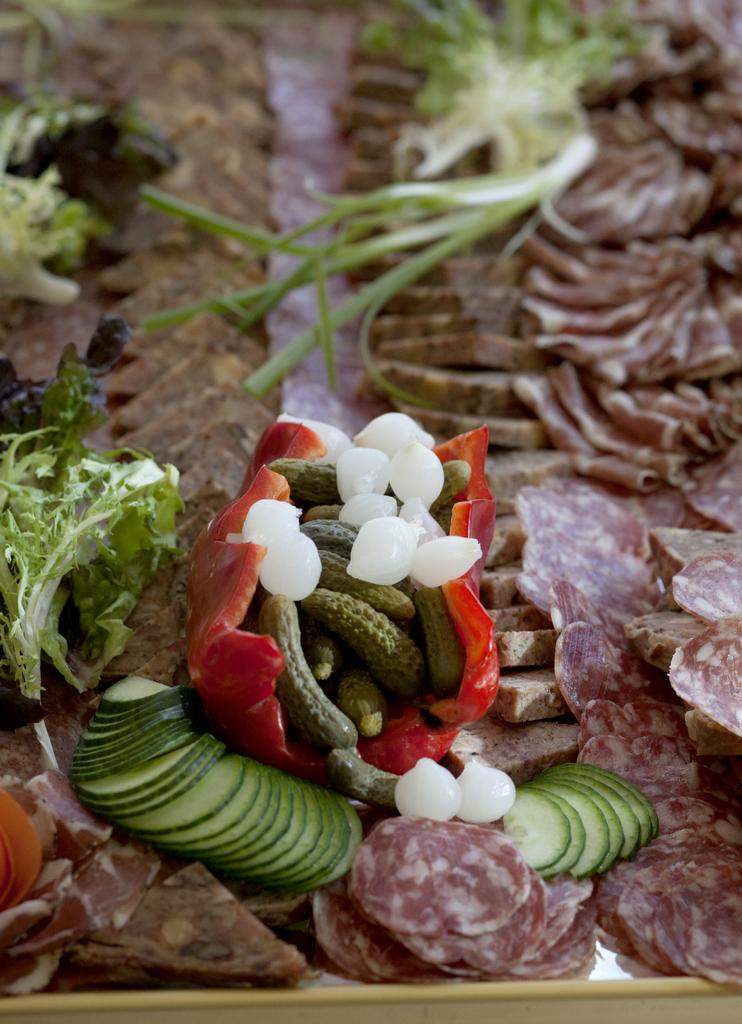What type of food can be seen in the image? The image contains slices of vegetables and groundnuts. How are the vegetables and groundnuts arranged in the image? The vegetables and groundnuts are kept in a tray. What type of knot can be seen in the image? There is no knot present in the image; it features slices of vegetables and groundnuts in a tray. 